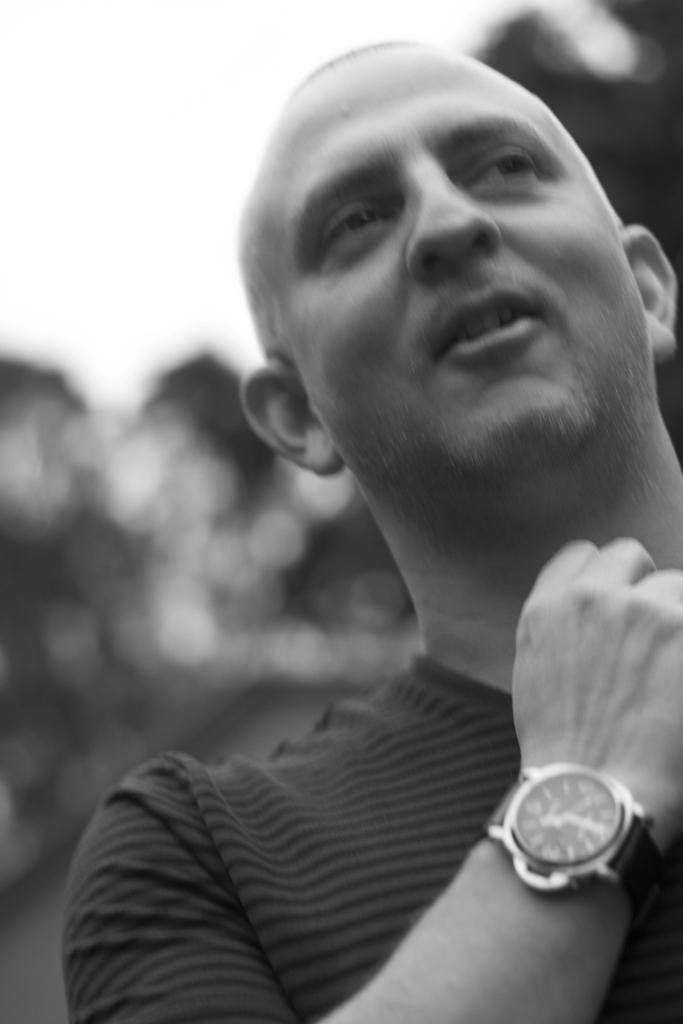Who or what is present in the image? There is a person in the image. What accessory is the person wearing? The person is wearing a watch. What can be seen in the distance behind the person? There are trees visible in the background of the image. What type of quiver is the person holding in the image? There is no quiver present in the image; the person is only wearing a watch. 